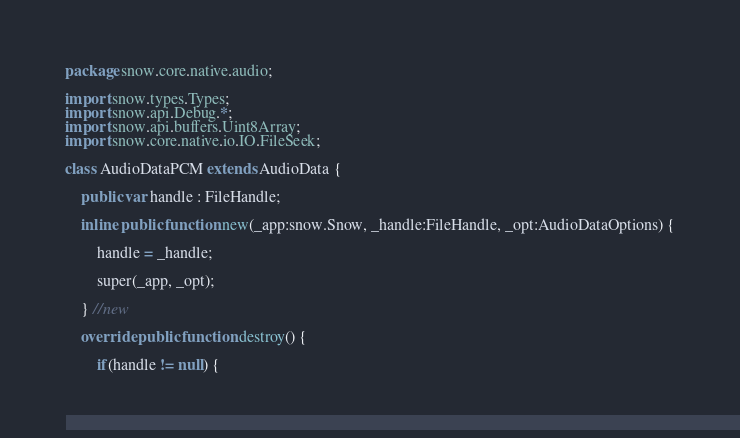<code> <loc_0><loc_0><loc_500><loc_500><_Haxe_>package snow.core.native.audio;

import snow.types.Types;
import snow.api.Debug.*;
import snow.api.buffers.Uint8Array;
import snow.core.native.io.IO.FileSeek;

class AudioDataPCM extends AudioData {

    public var handle : FileHandle;

    inline public function new(_app:snow.Snow, _handle:FileHandle, _opt:AudioDataOptions) {

        handle = _handle;

        super(_app, _opt);

    } //new

    override public function destroy() {

        if(handle != null) {</code> 